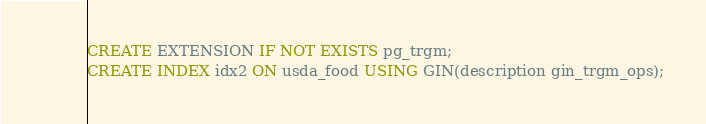<code> <loc_0><loc_0><loc_500><loc_500><_SQL_>CREATE EXTENSION IF NOT EXISTS pg_trgm;
CREATE INDEX idx2 ON usda_food USING GIN(description gin_trgm_ops);</code> 